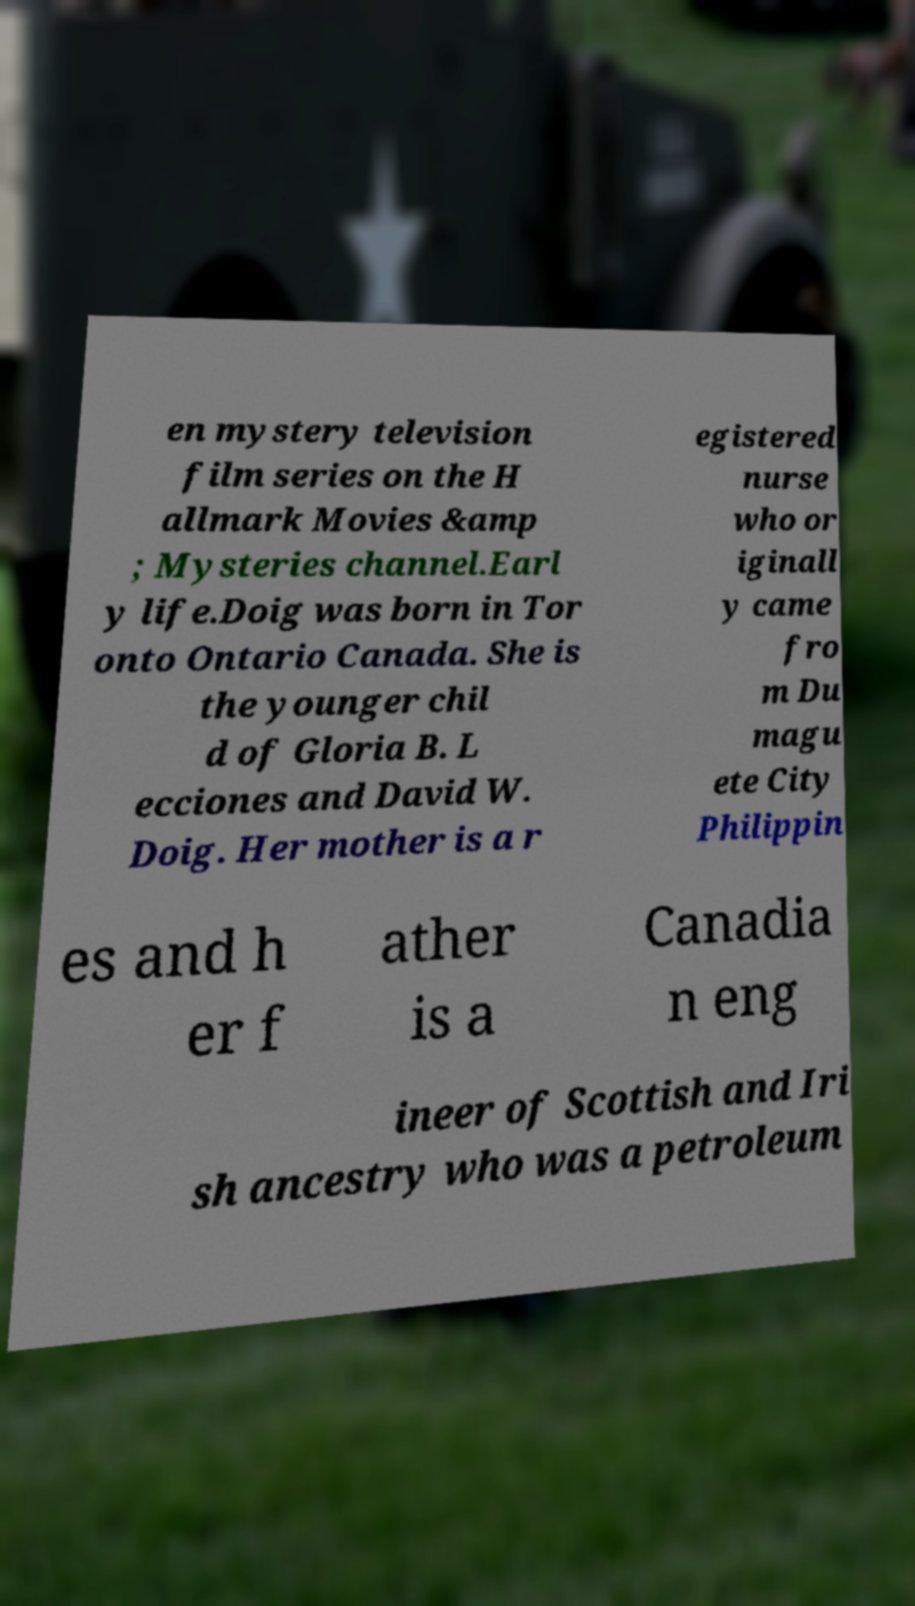Could you extract and type out the text from this image? en mystery television film series on the H allmark Movies &amp ; Mysteries channel.Earl y life.Doig was born in Tor onto Ontario Canada. She is the younger chil d of Gloria B. L ecciones and David W. Doig. Her mother is a r egistered nurse who or iginall y came fro m Du magu ete City Philippin es and h er f ather is a Canadia n eng ineer of Scottish and Iri sh ancestry who was a petroleum 